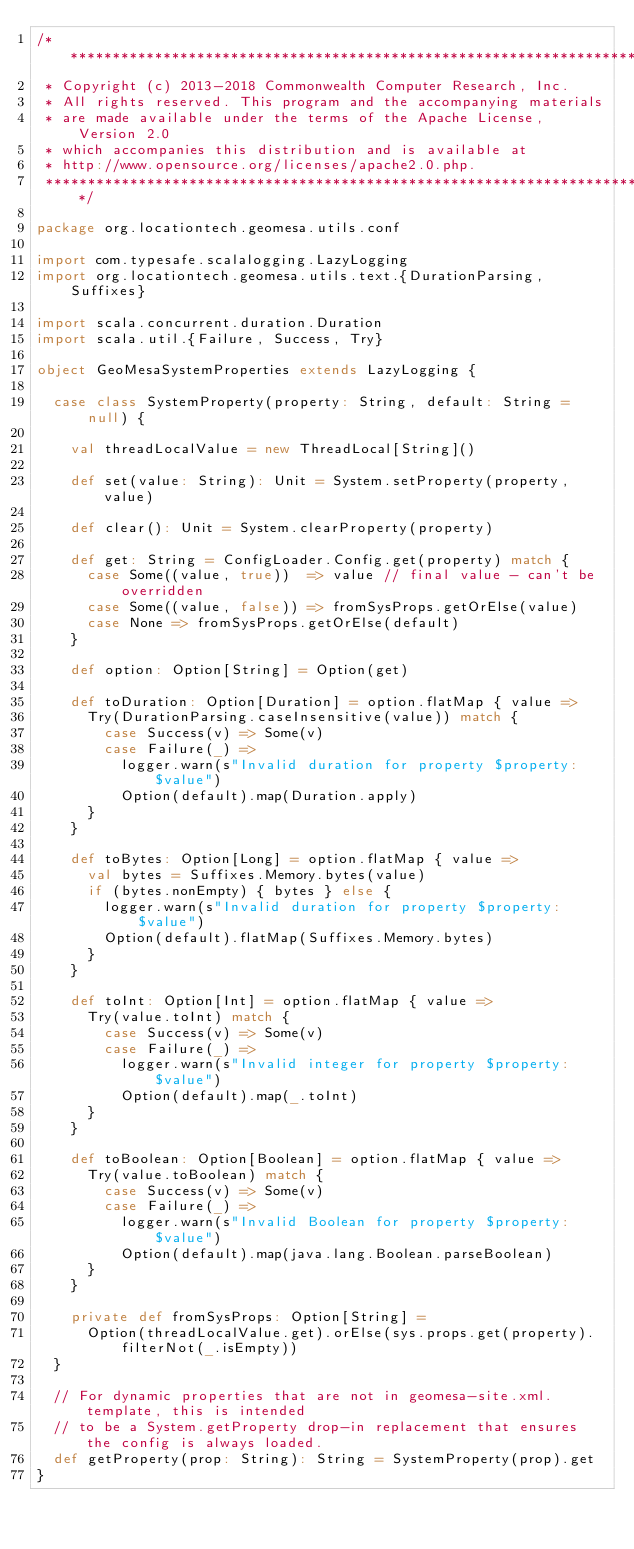Convert code to text. <code><loc_0><loc_0><loc_500><loc_500><_Scala_>/***********************************************************************
 * Copyright (c) 2013-2018 Commonwealth Computer Research, Inc.
 * All rights reserved. This program and the accompanying materials
 * are made available under the terms of the Apache License, Version 2.0
 * which accompanies this distribution and is available at
 * http://www.opensource.org/licenses/apache2.0.php.
 ***********************************************************************/

package org.locationtech.geomesa.utils.conf

import com.typesafe.scalalogging.LazyLogging
import org.locationtech.geomesa.utils.text.{DurationParsing, Suffixes}

import scala.concurrent.duration.Duration
import scala.util.{Failure, Success, Try}

object GeoMesaSystemProperties extends LazyLogging {

  case class SystemProperty(property: String, default: String = null) {

    val threadLocalValue = new ThreadLocal[String]()

    def set(value: String): Unit = System.setProperty(property, value)

    def clear(): Unit = System.clearProperty(property)

    def get: String = ConfigLoader.Config.get(property) match {
      case Some((value, true))  => value // final value - can't be overridden
      case Some((value, false)) => fromSysProps.getOrElse(value)
      case None => fromSysProps.getOrElse(default)
    }

    def option: Option[String] = Option(get)

    def toDuration: Option[Duration] = option.flatMap { value =>
      Try(DurationParsing.caseInsensitive(value)) match {
        case Success(v) => Some(v)
        case Failure(_) =>
          logger.warn(s"Invalid duration for property $property: $value")
          Option(default).map(Duration.apply)
      }
    }

    def toBytes: Option[Long] = option.flatMap { value =>
      val bytes = Suffixes.Memory.bytes(value)
      if (bytes.nonEmpty) { bytes } else {
        logger.warn(s"Invalid duration for property $property: $value")
        Option(default).flatMap(Suffixes.Memory.bytes)
      }
    }

    def toInt: Option[Int] = option.flatMap { value =>
      Try(value.toInt) match {
        case Success(v) => Some(v)
        case Failure(_) =>
          logger.warn(s"Invalid integer for property $property: $value")
          Option(default).map(_.toInt)
      }
    }

    def toBoolean: Option[Boolean] = option.flatMap { value =>
      Try(value.toBoolean) match {
        case Success(v) => Some(v)
        case Failure(_) =>
          logger.warn(s"Invalid Boolean for property $property: $value")
          Option(default).map(java.lang.Boolean.parseBoolean)
      }
    }

    private def fromSysProps: Option[String] =
      Option(threadLocalValue.get).orElse(sys.props.get(property).filterNot(_.isEmpty))
  }

  // For dynamic properties that are not in geomesa-site.xml.template, this is intended
  // to be a System.getProperty drop-in replacement that ensures the config is always loaded.
  def getProperty(prop: String): String = SystemProperty(prop).get
}

</code> 